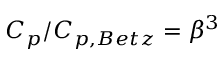<formula> <loc_0><loc_0><loc_500><loc_500>C _ { p } / C _ { p , B e t z } = \beta ^ { 3 }</formula> 